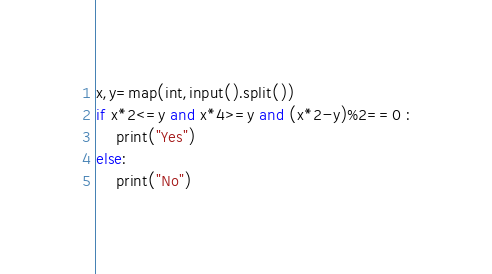<code> <loc_0><loc_0><loc_500><loc_500><_Python_>x,y=map(int,input().split())
if x*2<=y and x*4>=y and (x*2-y)%2==0 :
    print("Yes")
else:
    print("No")
</code> 